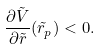Convert formula to latex. <formula><loc_0><loc_0><loc_500><loc_500>\frac { \partial \tilde { V } } { \partial \tilde { r } } ( \tilde { r } _ { p } ) < 0 .</formula> 